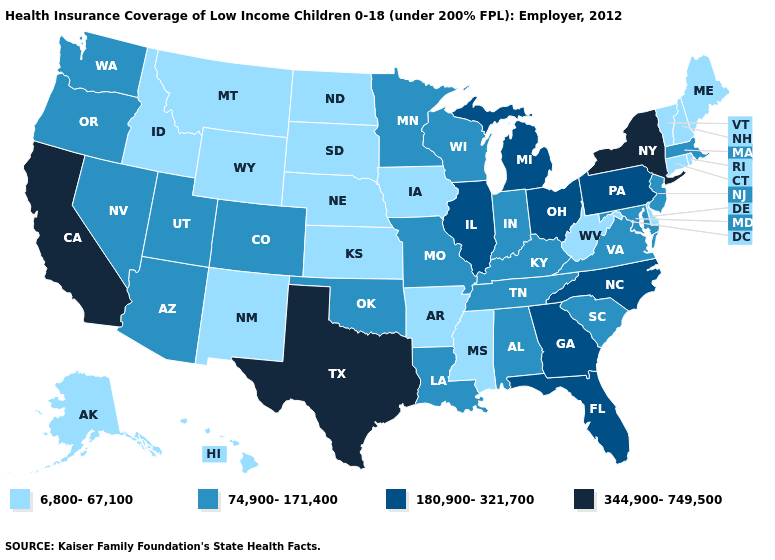What is the lowest value in states that border West Virginia?
Answer briefly. 74,900-171,400. Name the states that have a value in the range 180,900-321,700?
Give a very brief answer. Florida, Georgia, Illinois, Michigan, North Carolina, Ohio, Pennsylvania. What is the lowest value in the Northeast?
Quick response, please. 6,800-67,100. Which states have the lowest value in the USA?
Keep it brief. Alaska, Arkansas, Connecticut, Delaware, Hawaii, Idaho, Iowa, Kansas, Maine, Mississippi, Montana, Nebraska, New Hampshire, New Mexico, North Dakota, Rhode Island, South Dakota, Vermont, West Virginia, Wyoming. What is the value of Arkansas?
Quick response, please. 6,800-67,100. What is the value of Washington?
Be succinct. 74,900-171,400. Among the states that border Florida , which have the highest value?
Be succinct. Georgia. Does New Jersey have a higher value than West Virginia?
Concise answer only. Yes. Does the map have missing data?
Short answer required. No. What is the value of Vermont?
Concise answer only. 6,800-67,100. Does Illinois have the highest value in the MidWest?
Keep it brief. Yes. What is the value of Nevada?
Answer briefly. 74,900-171,400. What is the value of Georgia?
Short answer required. 180,900-321,700. What is the highest value in the USA?
Concise answer only. 344,900-749,500. Which states have the lowest value in the USA?
Keep it brief. Alaska, Arkansas, Connecticut, Delaware, Hawaii, Idaho, Iowa, Kansas, Maine, Mississippi, Montana, Nebraska, New Hampshire, New Mexico, North Dakota, Rhode Island, South Dakota, Vermont, West Virginia, Wyoming. 